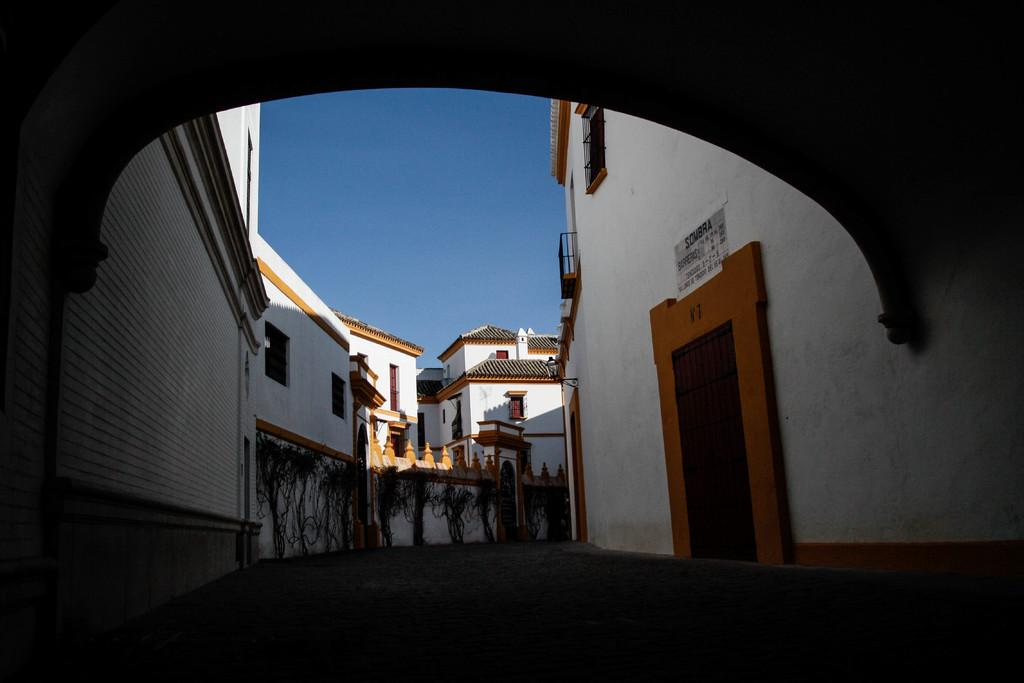What type of structures can be seen in the image? There are buildings in the image. What is written or displayed on a wall in the image? There is a board with text on a wall in the image. What type of vegetation is present in the image? There are creepers in the image. What is visible at the top of the image? The sky is visible at the top of the image. What is located at the bottom of the image? There is a road at the bottom of the image. What type of activity is the bike involved in within the image? There is no bike present in the image. What route is the bike taking in the image? Since there is no bike in the image, it is not possible to determine the route it might be taking. 